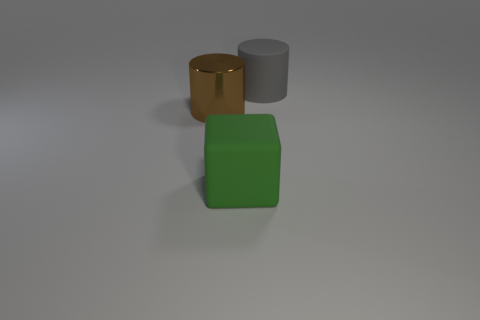How many spheres are large gray things or large green metal things?
Your answer should be compact. 0. There is a big thing that is to the left of the rubber thing that is left of the large matte cylinder; what is its color?
Offer a very short reply. Brown. What is the shape of the large metal thing?
Give a very brief answer. Cylinder. Are there any blue cylinders made of the same material as the block?
Offer a very short reply. No. How many things are things that are to the right of the metallic thing or large metal blocks?
Offer a terse response. 2. Is there a purple rubber ball?
Offer a terse response. No. What shape is the thing that is both in front of the large rubber cylinder and to the right of the brown object?
Keep it short and to the point. Cube. There is a cylinder that is behind the large brown metal thing; what size is it?
Ensure brevity in your answer.  Large. How many big rubber objects have the same shape as the large brown metallic object?
Offer a very short reply. 1. What number of objects are either rubber things to the right of the large green cube or things on the right side of the block?
Give a very brief answer. 1. 